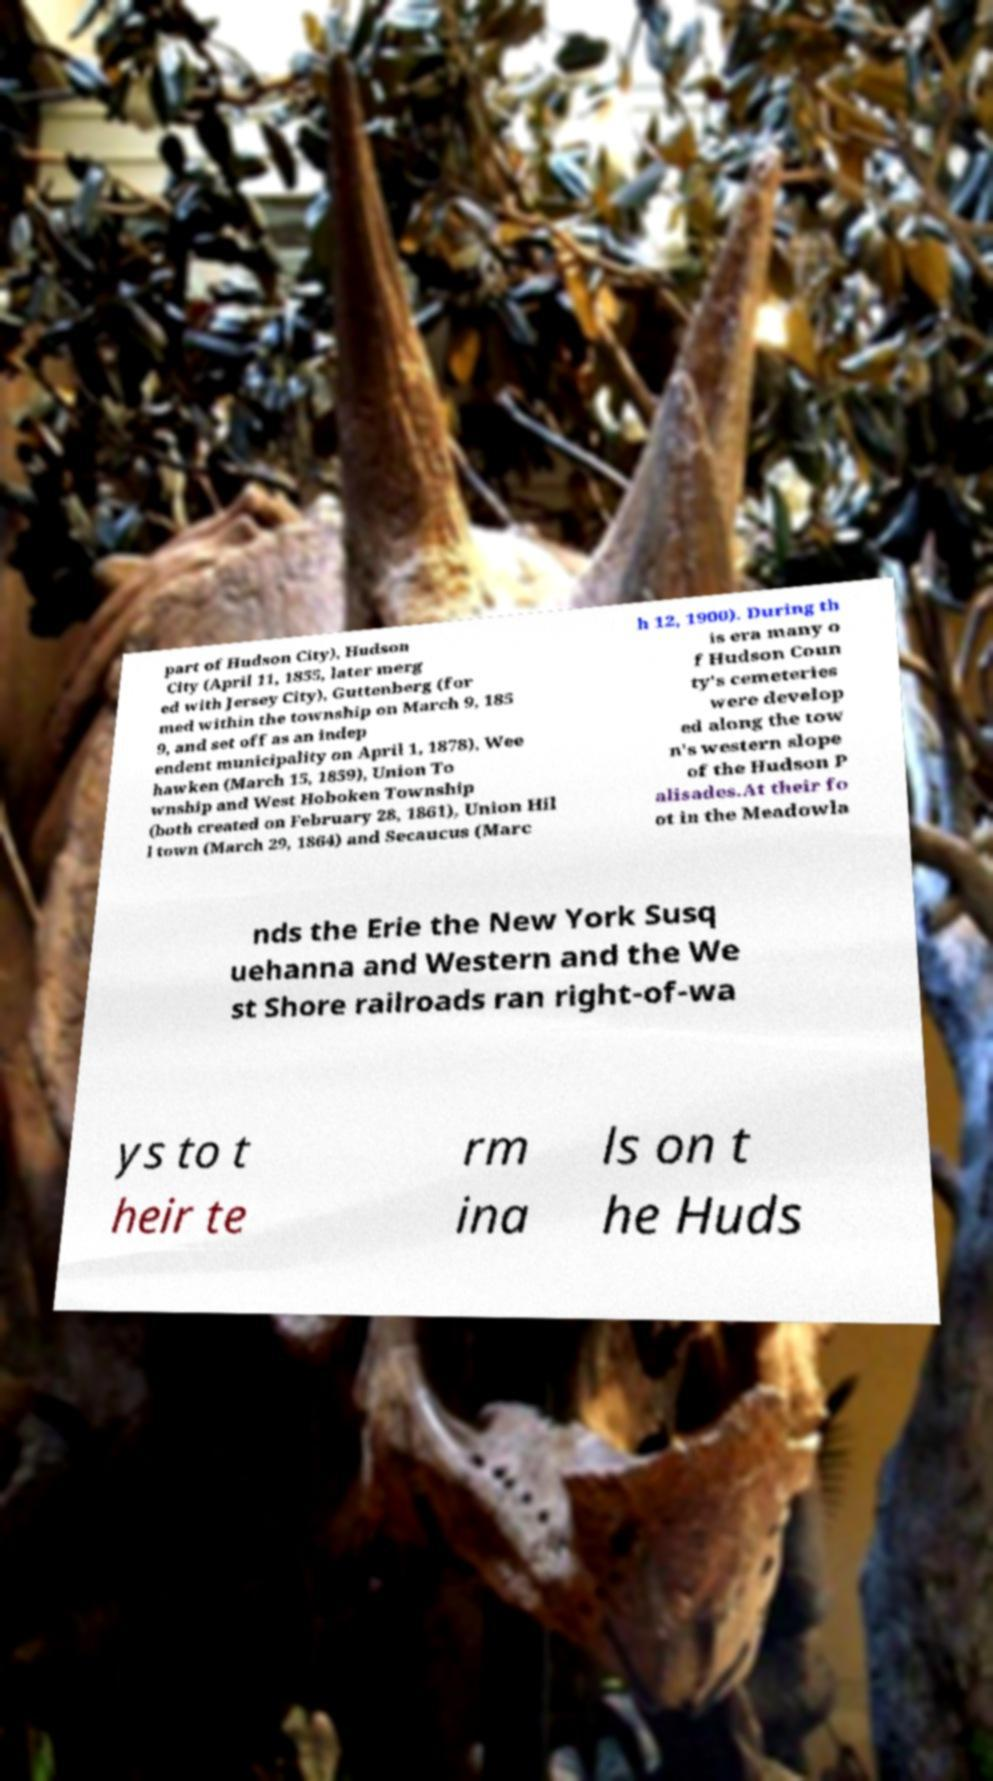There's text embedded in this image that I need extracted. Can you transcribe it verbatim? part of Hudson City), Hudson City (April 11, 1855, later merg ed with Jersey City), Guttenberg (for med within the township on March 9, 185 9, and set off as an indep endent municipality on April 1, 1878), Wee hawken (March 15, 1859), Union To wnship and West Hoboken Township (both created on February 28, 1861), Union Hil l town (March 29, 1864) and Secaucus (Marc h 12, 1900). During th is era many o f Hudson Coun ty's cemeteries were develop ed along the tow n's western slope of the Hudson P alisades.At their fo ot in the Meadowla nds the Erie the New York Susq uehanna and Western and the We st Shore railroads ran right-of-wa ys to t heir te rm ina ls on t he Huds 